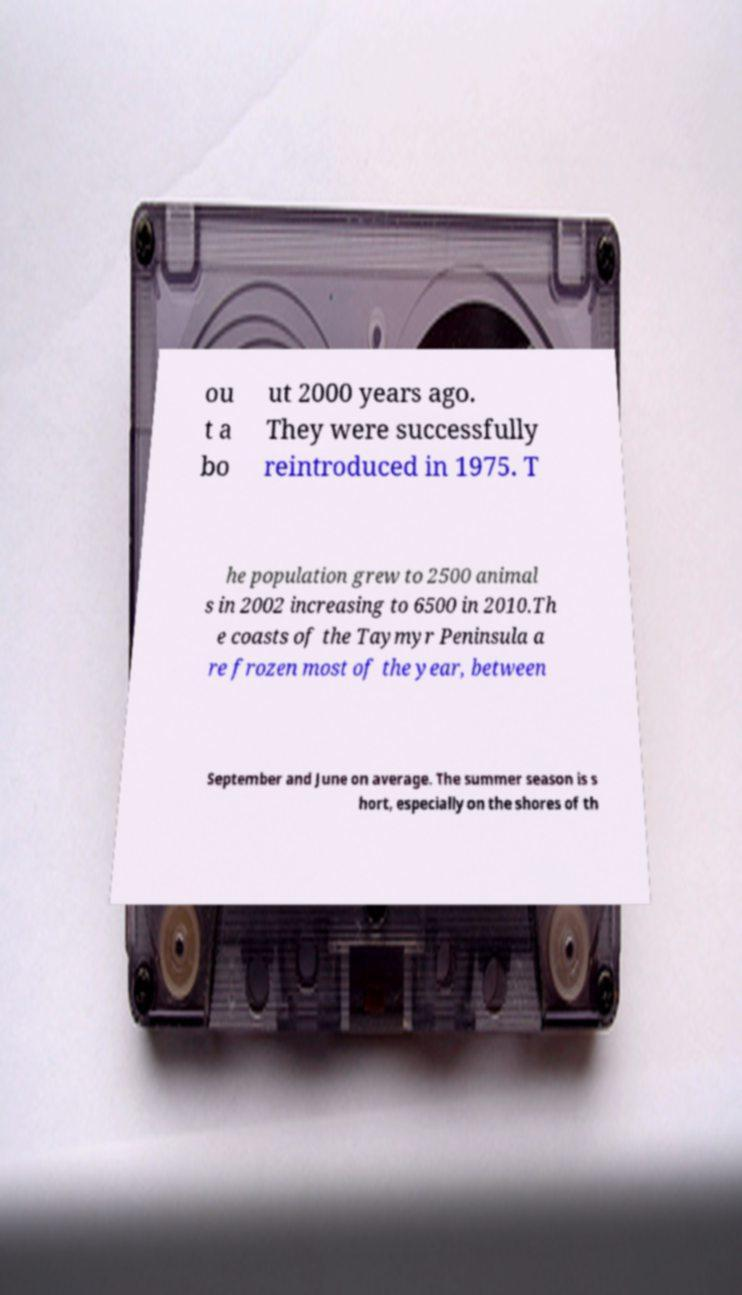Please identify and transcribe the text found in this image. ou t a bo ut 2000 years ago. They were successfully reintroduced in 1975. T he population grew to 2500 animal s in 2002 increasing to 6500 in 2010.Th e coasts of the Taymyr Peninsula a re frozen most of the year, between September and June on average. The summer season is s hort, especially on the shores of th 